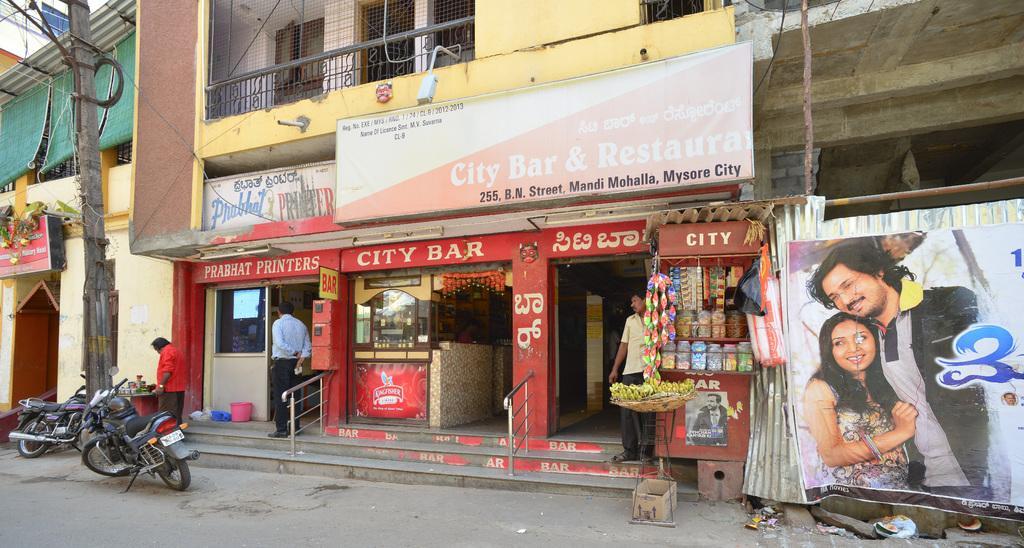Describe this image in one or two sentences. In this image I can see few stores, few buildings and on it I can see number of boards. I can also see something is written on these boards. In the front I can see few vehicles, few people, a box and on the right side of the image I can see a poster. I can also see a pole and few wires on the left side and I can also see few stuffs in the background. 